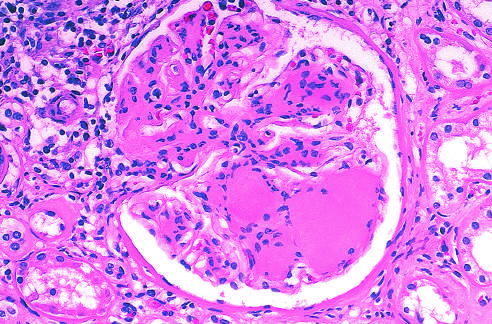does the renal glomerulus show markedly thickend glomerular basement membrane in a diabetic?
Answer the question using a single word or phrase. Yes 